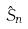Convert formula to latex. <formula><loc_0><loc_0><loc_500><loc_500>\hat { S } _ { n }</formula> 